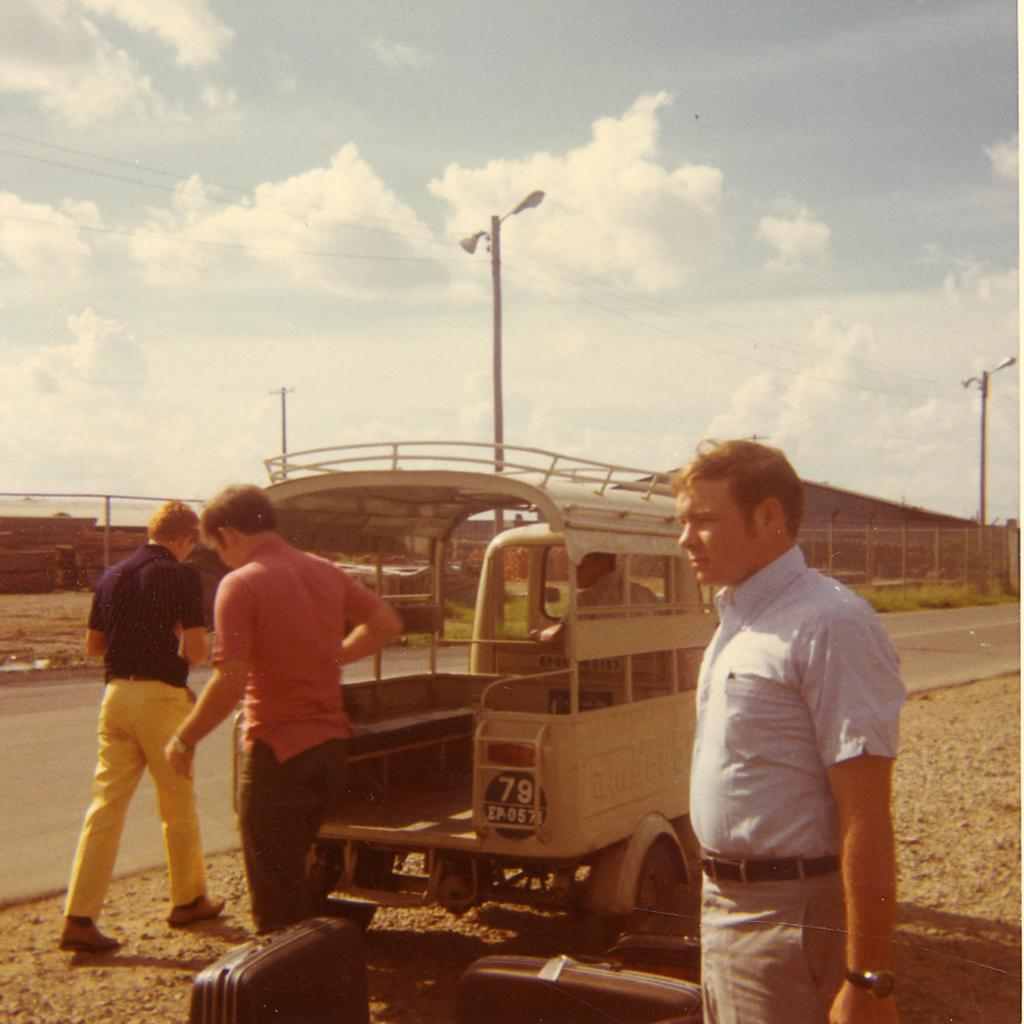What can be seen in the foreground of the image? In the foreground of the image, there are people, a vehicle, and suitcases. What is located in the background of the image? In the background of the image, there are poles, a boundary, sheds, and the sky. How many people are visible in the image? The number of people visible in the image is not specified, but there are people in the foreground. What type of vehicle is present in the image? The type of vehicle in the image is not specified, but there is a vehicle in the foreground. What type of earth can be seen in the image? There is no specific type of earth mentioned or visible in the image. What kind of pleasure can be experienced by the people in the image? The image does not provide any information about the emotions or experiences of the people, so it is impossible to determine what kind of pleasure they might be experiencing. 